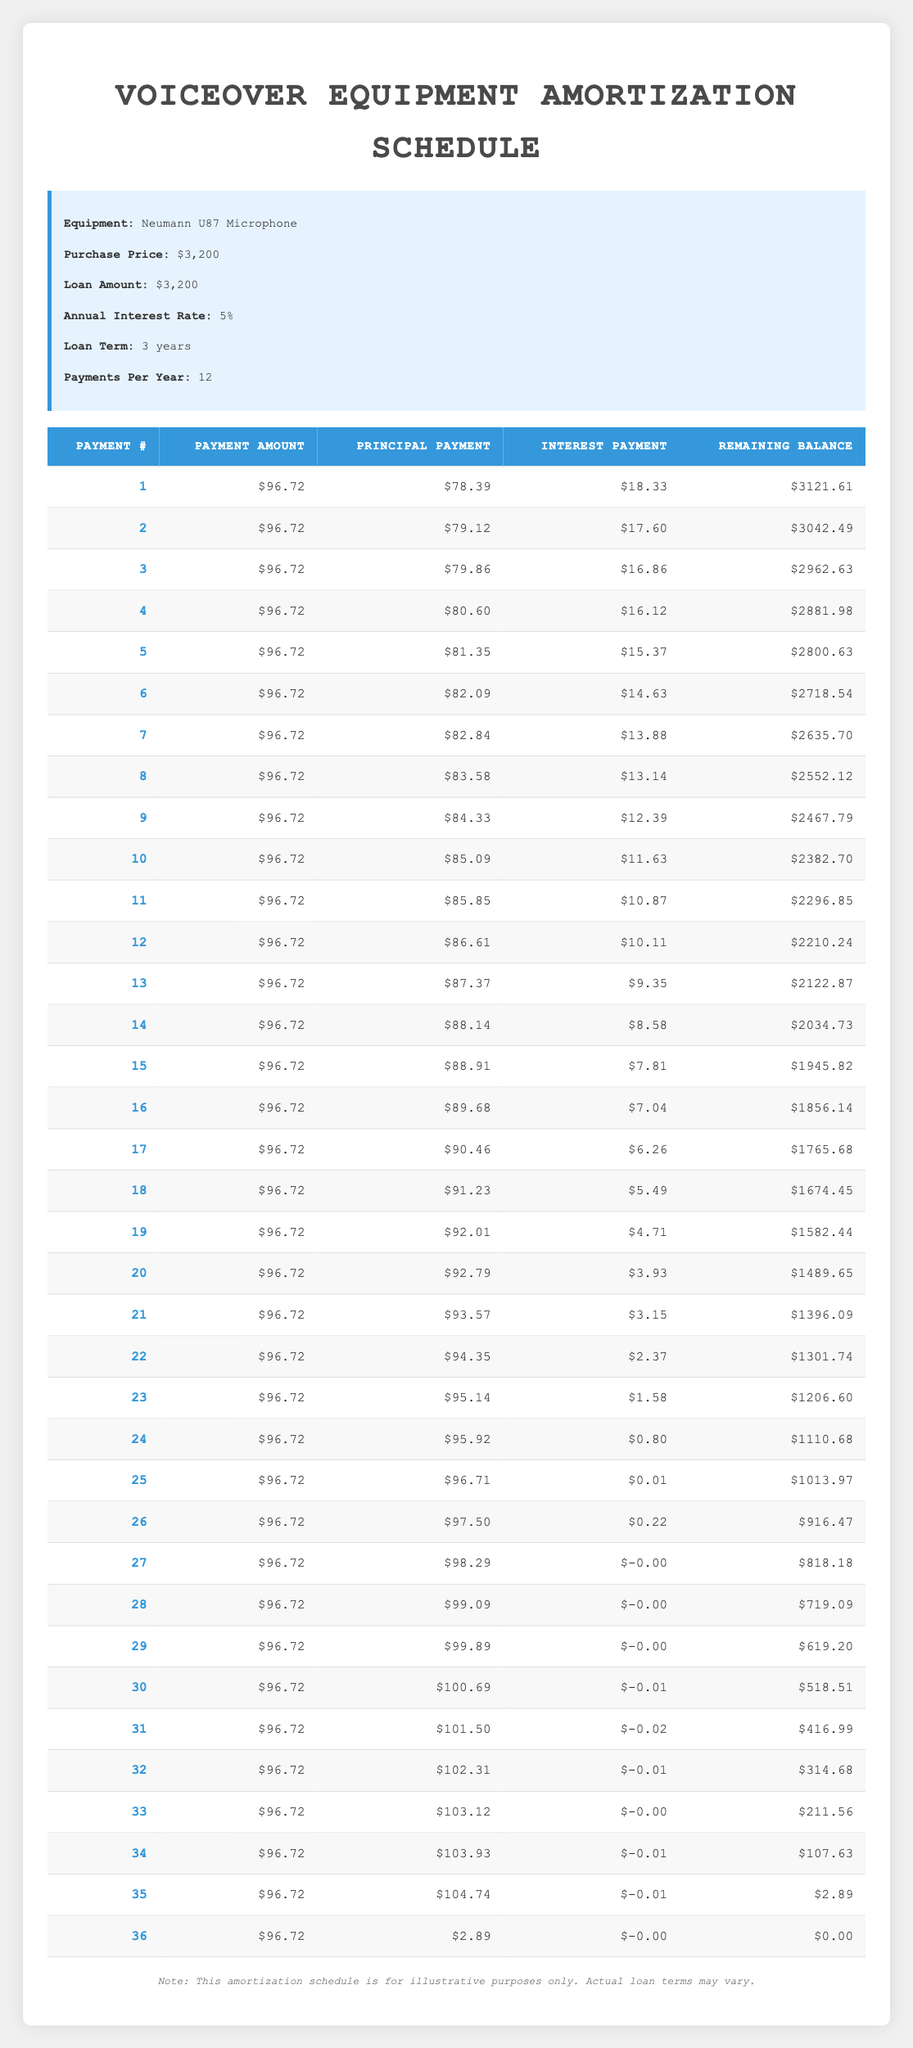What is the total payment amount over the entire loan term? The loan term is 3 years with 12 payments per year, making a total of 36 payments. Each payment is $96.72. Thus, the total payment amount is 36 * 96.72 = $3,487.92.
Answer: $3,487.92 What is the amount of principal paid in the first payment? The principal payment in the first row of the table is stated as $78.39.
Answer: $78.39 How much interest will be paid in the final payment? The last row shows an interest payment of $0.00 for the 36th payment.
Answer: $0.00 Is the total interest paid over the entire loan term more than $200? To find the total interest paid, we can look at the interest payments for all 36 payments. Adding up these amounts results in $118.95 which is less than $200.
Answer: No What is the remaining balance after the 12th payment? The table indicates that after the 12th payment, the remaining balance is $2,210.24.
Answer: $2,210.24 How does the amount of principal paid change in the first six payments? The principal payments for the first six payments are $78.39, $79.12, $79.86, $80.60, $81.35, and $82.09. The differences show a gradual increase of approximately $0.73 each time.
Answer: Increases by about $0.73 each payment What is the average monthly payment amount? The total payment amount is $3,487.92 over 36 payments. Dividing this by 36 gives an average monthly payment of $96.72.
Answer: $96.72 What percentage of the monthly payment is allocated to interest in the first payment? The interest payment for the first payment is $18.33. To find the percentage, divide $18.33 by $96.72 and multiply by 100, which gives approximately 18.95%.
Answer: 18.95% What is the total remaining balance after the 24th payment? According to the table, the remaining balance after the 24th payment is $1,110.68.
Answer: $1,110.68 